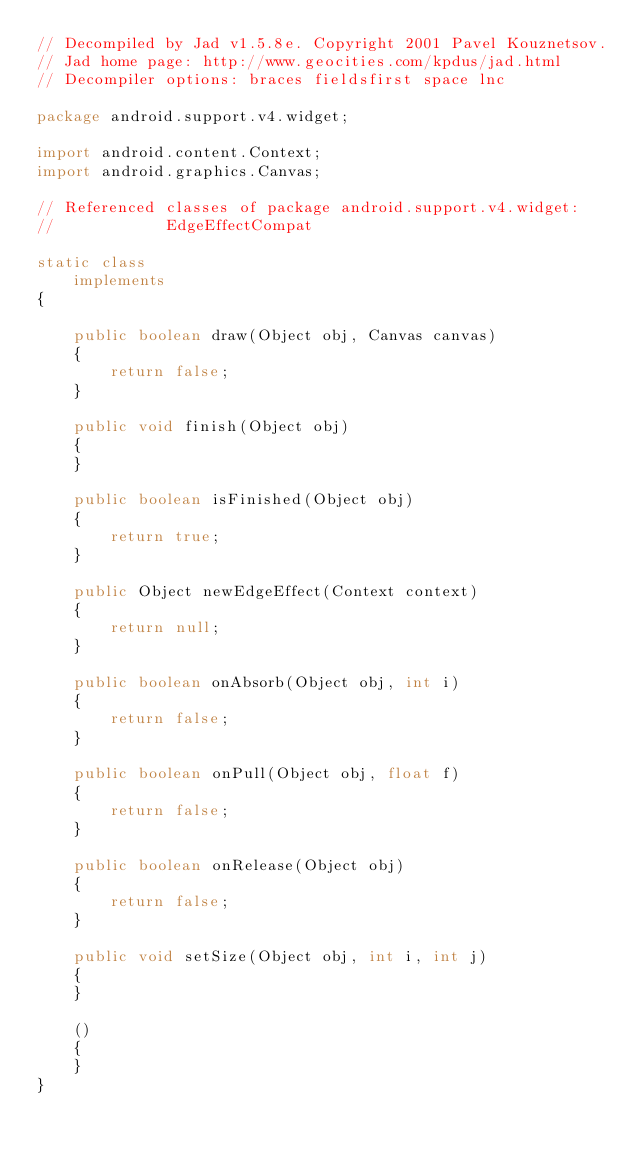Convert code to text. <code><loc_0><loc_0><loc_500><loc_500><_Java_>// Decompiled by Jad v1.5.8e. Copyright 2001 Pavel Kouznetsov.
// Jad home page: http://www.geocities.com/kpdus/jad.html
// Decompiler options: braces fieldsfirst space lnc 

package android.support.v4.widget;

import android.content.Context;
import android.graphics.Canvas;

// Referenced classes of package android.support.v4.widget:
//            EdgeEffectCompat

static class 
    implements 
{

    public boolean draw(Object obj, Canvas canvas)
    {
        return false;
    }

    public void finish(Object obj)
    {
    }

    public boolean isFinished(Object obj)
    {
        return true;
    }

    public Object newEdgeEffect(Context context)
    {
        return null;
    }

    public boolean onAbsorb(Object obj, int i)
    {
        return false;
    }

    public boolean onPull(Object obj, float f)
    {
        return false;
    }

    public boolean onRelease(Object obj)
    {
        return false;
    }

    public void setSize(Object obj, int i, int j)
    {
    }

    ()
    {
    }
}
</code> 